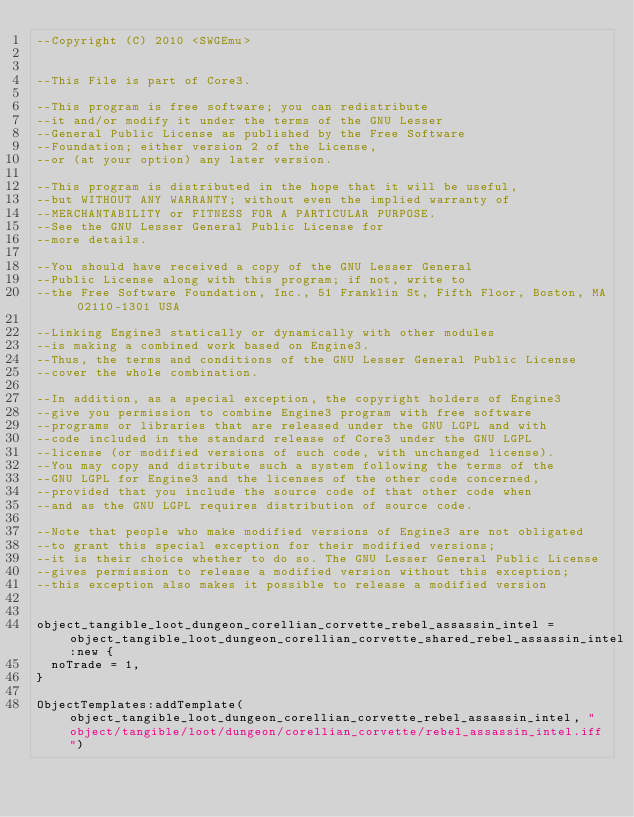Convert code to text. <code><loc_0><loc_0><loc_500><loc_500><_Lua_>--Copyright (C) 2010 <SWGEmu>


--This File is part of Core3.

--This program is free software; you can redistribute 
--it and/or modify it under the terms of the GNU Lesser 
--General Public License as published by the Free Software
--Foundation; either version 2 of the License, 
--or (at your option) any later version.

--This program is distributed in the hope that it will be useful, 
--but WITHOUT ANY WARRANTY; without even the implied warranty of 
--MERCHANTABILITY or FITNESS FOR A PARTICULAR PURPOSE. 
--See the GNU Lesser General Public License for
--more details.

--You should have received a copy of the GNU Lesser General 
--Public License along with this program; if not, write to
--the Free Software Foundation, Inc., 51 Franklin St, Fifth Floor, Boston, MA 02110-1301 USA

--Linking Engine3 statically or dynamically with other modules 
--is making a combined work based on Engine3. 
--Thus, the terms and conditions of the GNU Lesser General Public License 
--cover the whole combination.

--In addition, as a special exception, the copyright holders of Engine3 
--give you permission to combine Engine3 program with free software 
--programs or libraries that are released under the GNU LGPL and with 
--code included in the standard release of Core3 under the GNU LGPL 
--license (or modified versions of such code, with unchanged license). 
--You may copy and distribute such a system following the terms of the 
--GNU LGPL for Engine3 and the licenses of the other code concerned, 
--provided that you include the source code of that other code when 
--and as the GNU LGPL requires distribution of source code.

--Note that people who make modified versions of Engine3 are not obligated 
--to grant this special exception for their modified versions; 
--it is their choice whether to do so. The GNU Lesser General Public License 
--gives permission to release a modified version without this exception; 
--this exception also makes it possible to release a modified version 


object_tangible_loot_dungeon_corellian_corvette_rebel_assassin_intel = object_tangible_loot_dungeon_corellian_corvette_shared_rebel_assassin_intel:new {
	noTrade = 1,
}

ObjectTemplates:addTemplate(object_tangible_loot_dungeon_corellian_corvette_rebel_assassin_intel, "object/tangible/loot/dungeon/corellian_corvette/rebel_assassin_intel.iff")
</code> 